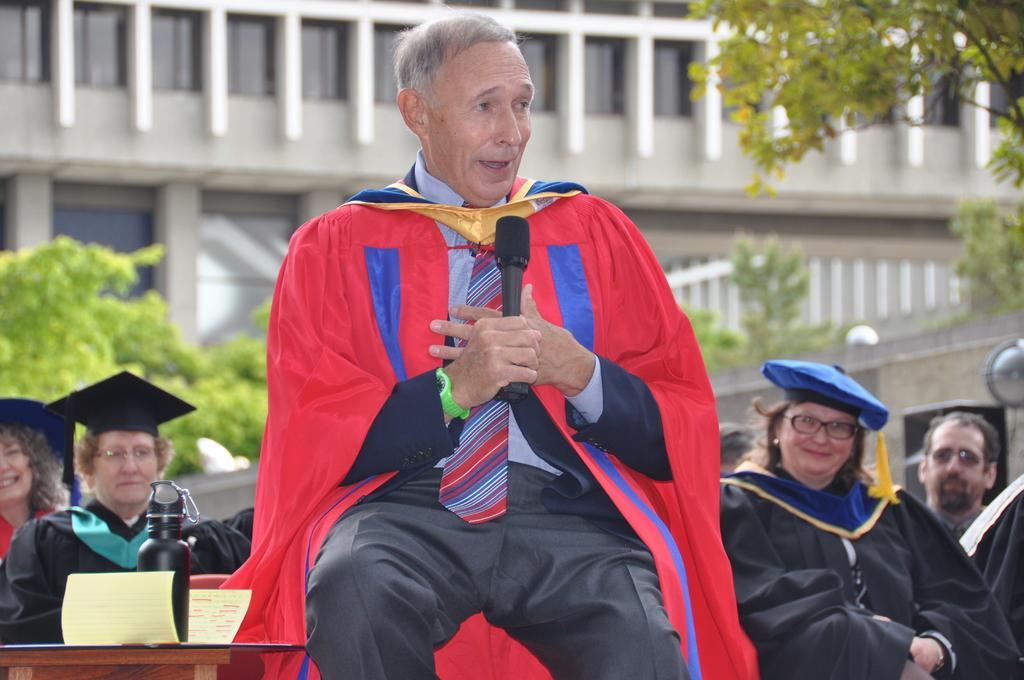Could you give a brief overview of what you see in this image? This image consists of many persons. It looks like a convocation. In the front, we can see a man wearing a red color coat and talking in a mic. On the left, we can see a table on which there is a paper along with a bottle. In the background, there are plants and a building. 